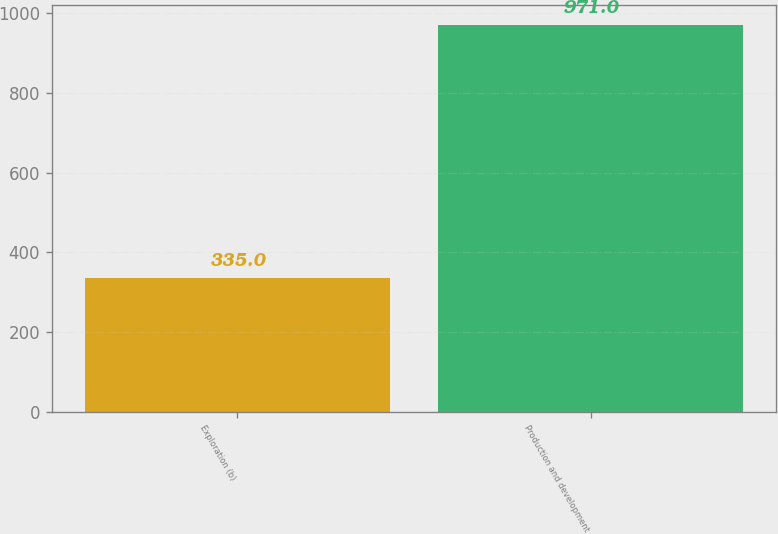Convert chart to OTSL. <chart><loc_0><loc_0><loc_500><loc_500><bar_chart><fcel>Exploration (b)<fcel>Production and development<nl><fcel>335<fcel>971<nl></chart> 